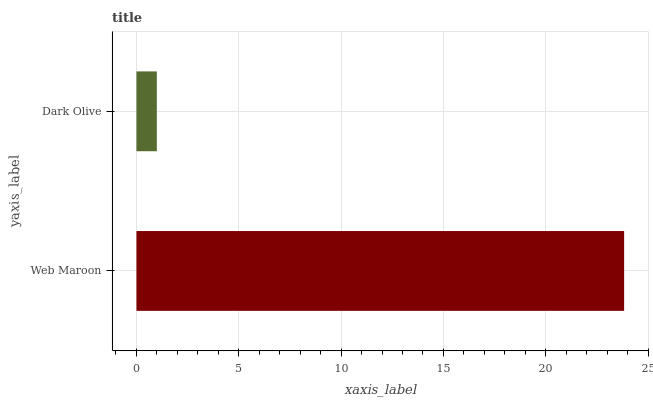Is Dark Olive the minimum?
Answer yes or no. Yes. Is Web Maroon the maximum?
Answer yes or no. Yes. Is Dark Olive the maximum?
Answer yes or no. No. Is Web Maroon greater than Dark Olive?
Answer yes or no. Yes. Is Dark Olive less than Web Maroon?
Answer yes or no. Yes. Is Dark Olive greater than Web Maroon?
Answer yes or no. No. Is Web Maroon less than Dark Olive?
Answer yes or no. No. Is Web Maroon the high median?
Answer yes or no. Yes. Is Dark Olive the low median?
Answer yes or no. Yes. Is Dark Olive the high median?
Answer yes or no. No. Is Web Maroon the low median?
Answer yes or no. No. 